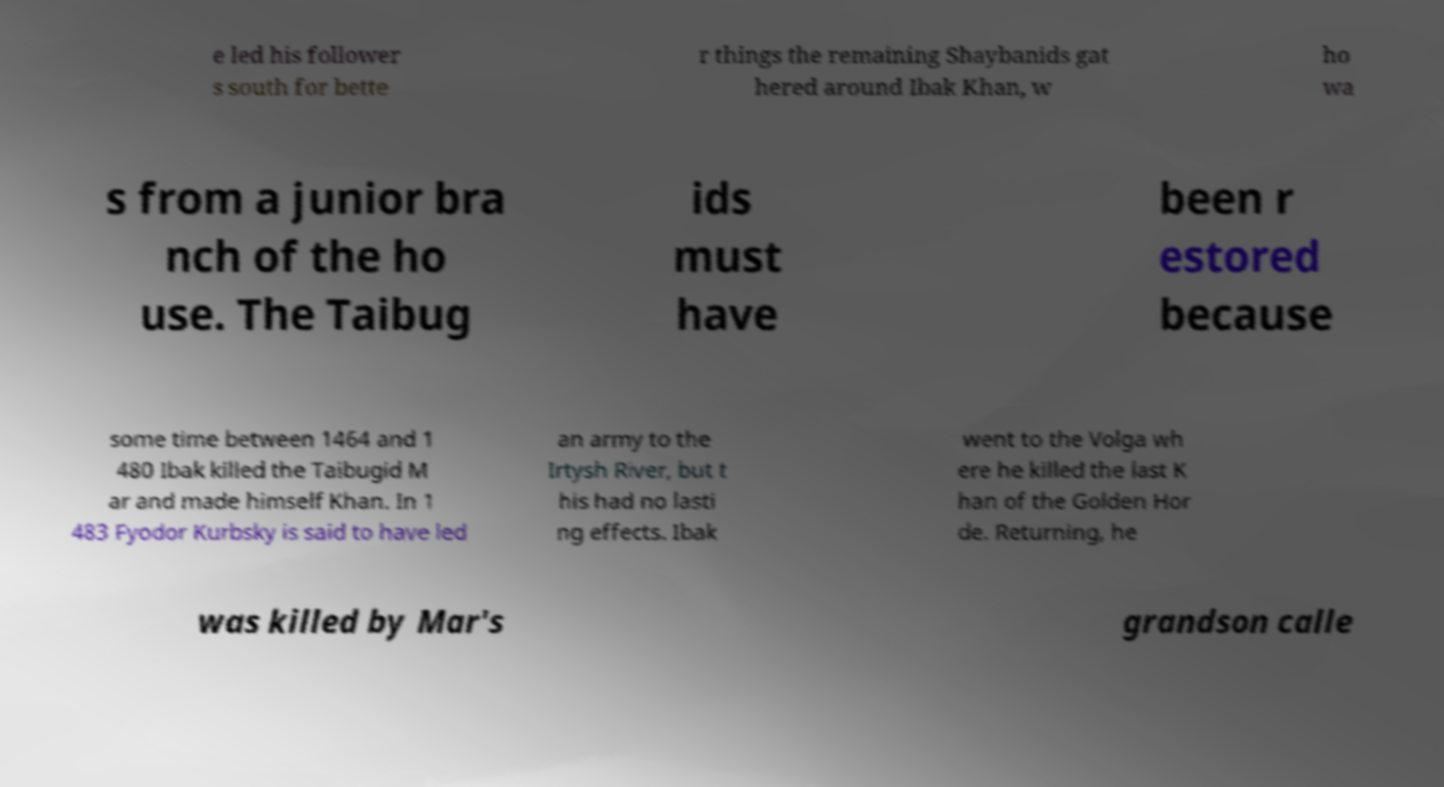Could you extract and type out the text from this image? e led his follower s south for bette r things the remaining Shaybanids gat hered around Ibak Khan, w ho wa s from a junior bra nch of the ho use. The Taibug ids must have been r estored because some time between 1464 and 1 480 Ibak killed the Taibugid M ar and made himself Khan. In 1 483 Fyodor Kurbsky is said to have led an army to the Irtysh River, but t his had no lasti ng effects. Ibak went to the Volga wh ere he killed the last K han of the Golden Hor de. Returning, he was killed by Mar's grandson calle 